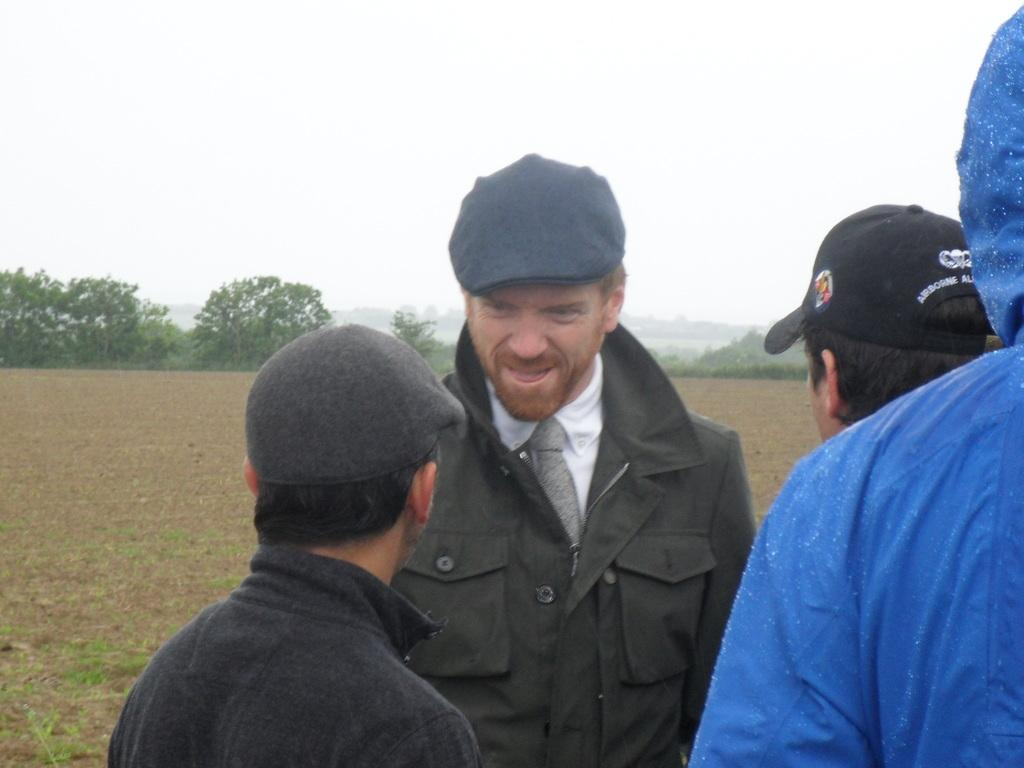How many people are present in the image? There are four people standing in front of the image. What is the surface at the bottom of the image made of? There is sand on the surface at the bottom of the image. What can be seen in the background of the image? There are trees, mountains, and the sky visible in the background of the image. What type of clover can be seen growing near the trees in the image? There is no clover visible in the image; only trees, mountains, and the sky are present in the background. How does the acoustics of the image affect the sound of the people's voices? The image does not provide any information about the acoustics or the sound of the people's voices. 